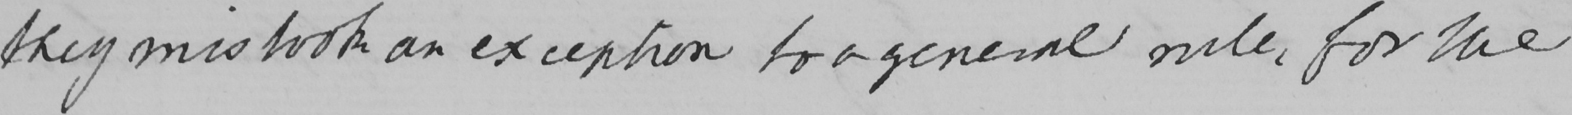Please provide the text content of this handwritten line. they mistook an exception to a general rule , for the 